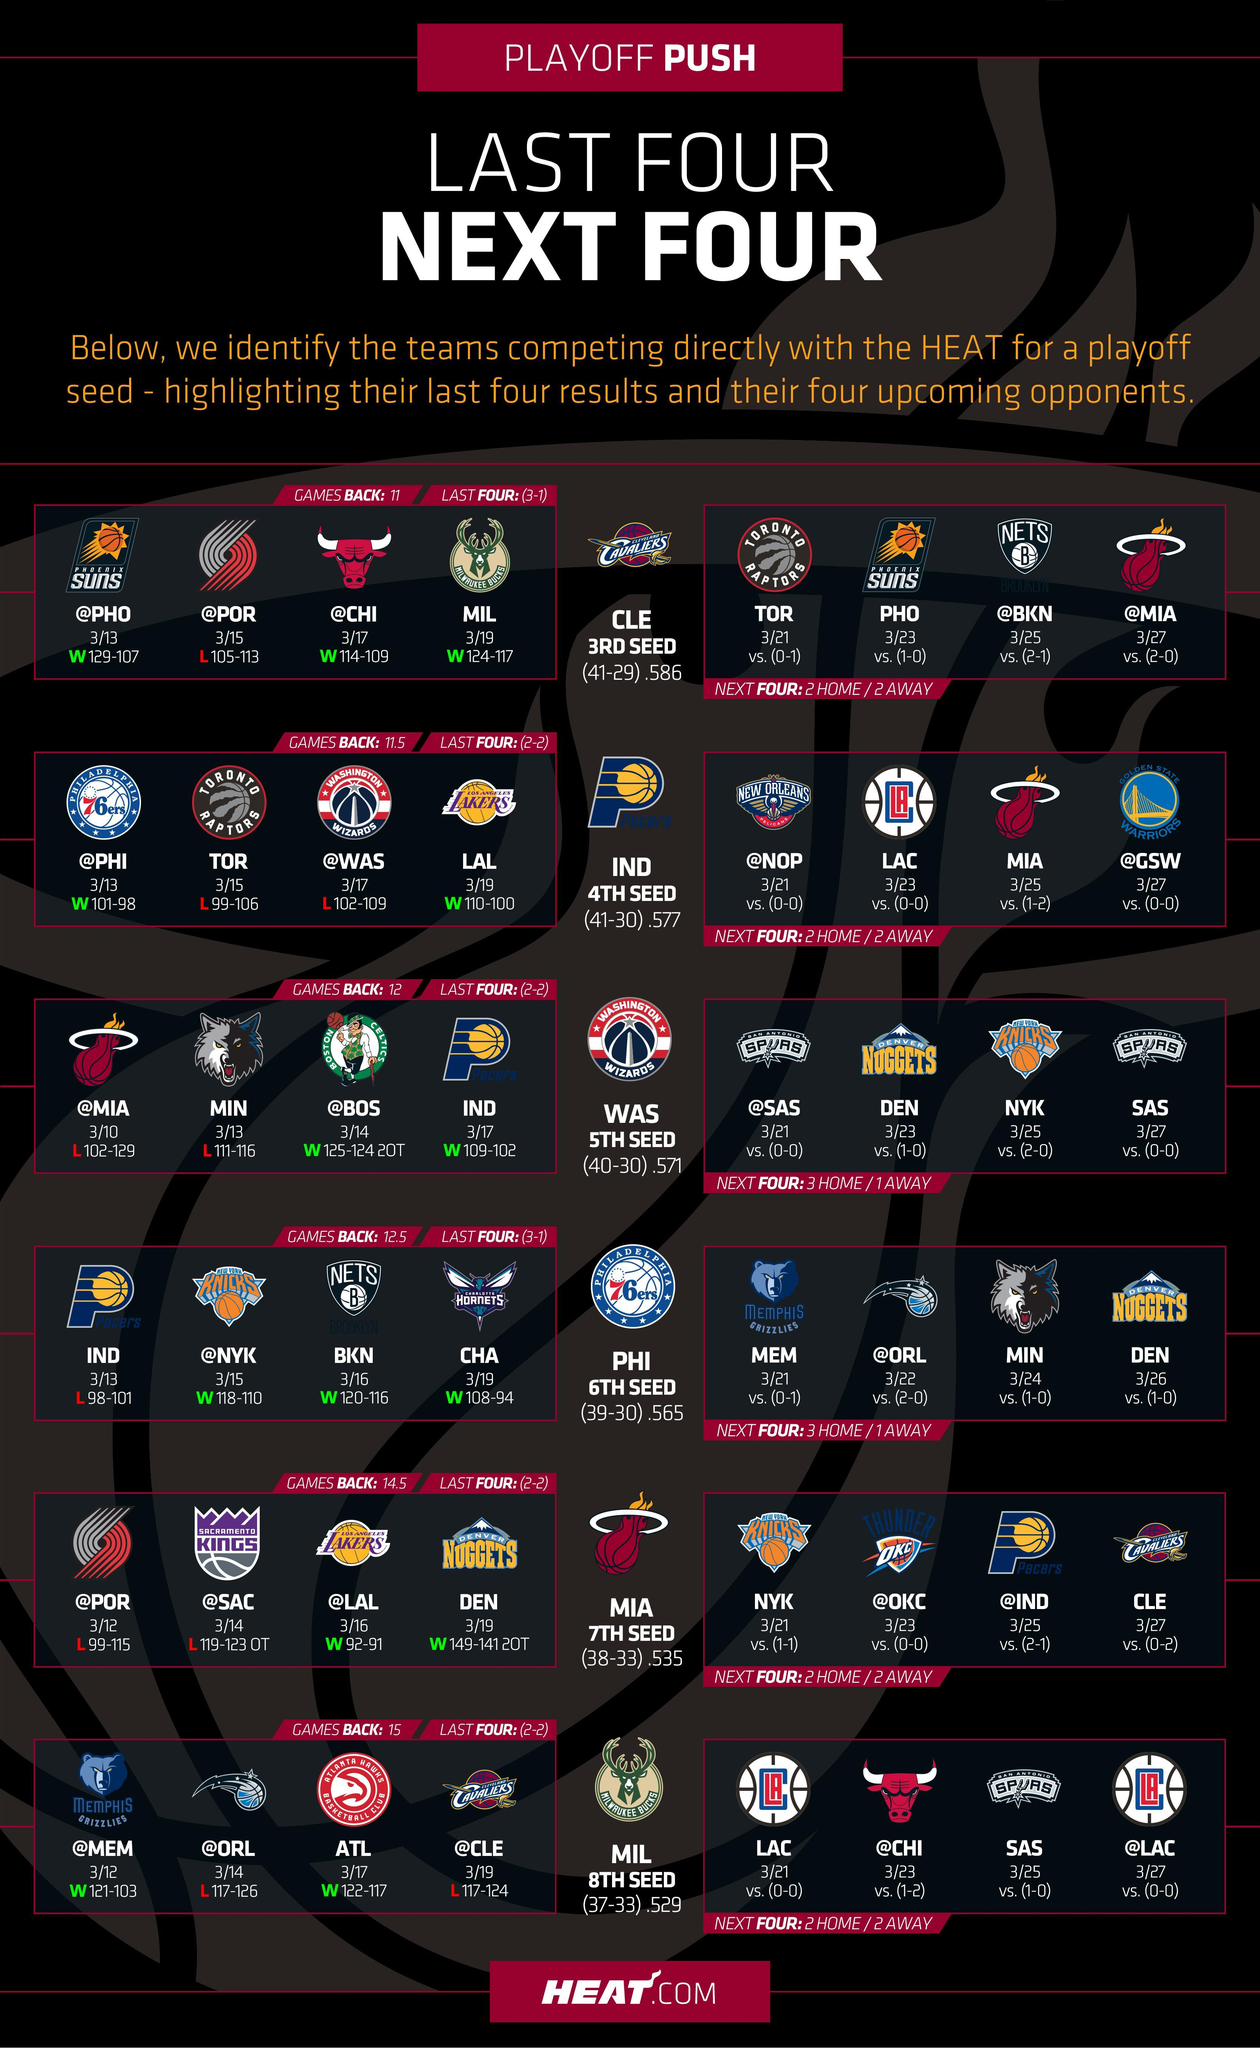How many rows are in this infographic?
Answer the question with a short phrase. 6 